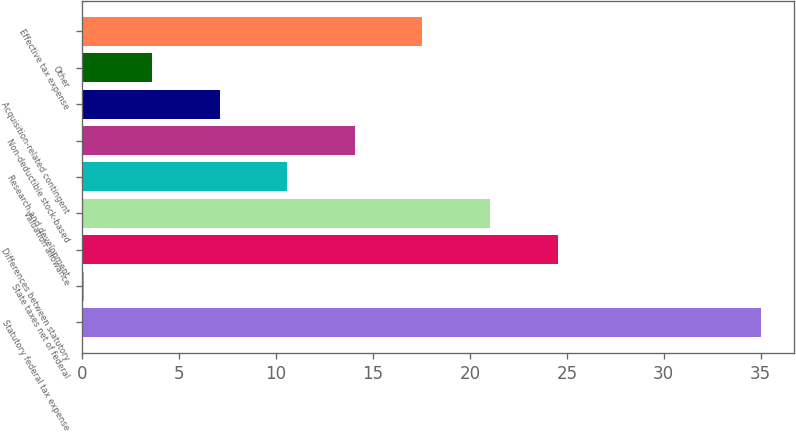<chart> <loc_0><loc_0><loc_500><loc_500><bar_chart><fcel>Statutory federal tax expense<fcel>State taxes net of federal<fcel>Differences between statutory<fcel>Valuation allowance<fcel>Research and development<fcel>Non-deductible stock-based<fcel>Acquisition-related contingent<fcel>Other<fcel>Effective tax expense<nl><fcel>35<fcel>0.1<fcel>24.53<fcel>21.04<fcel>10.57<fcel>14.06<fcel>7.08<fcel>3.59<fcel>17.55<nl></chart> 